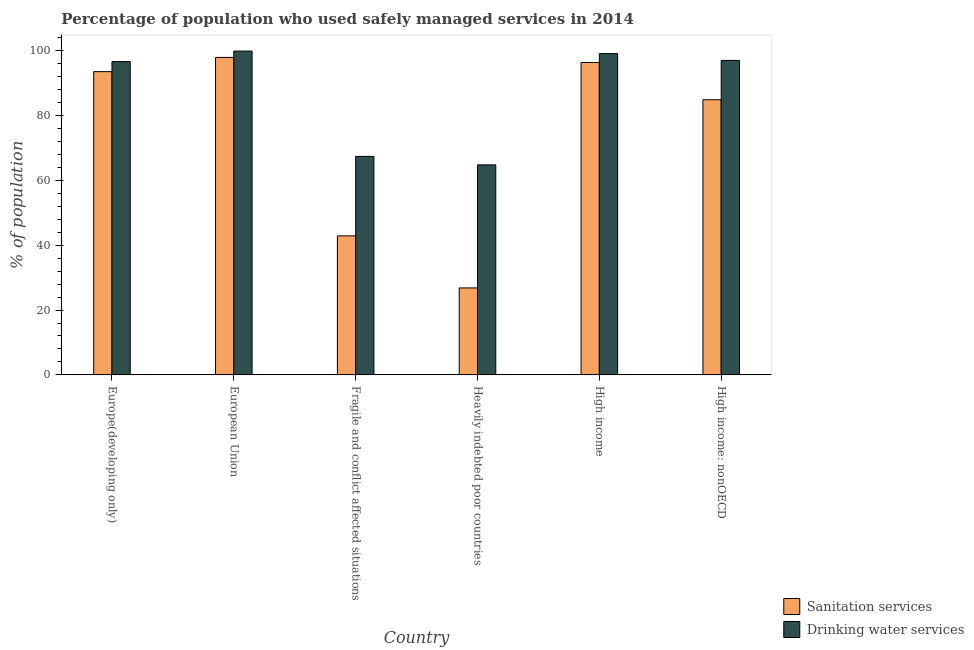How many different coloured bars are there?
Provide a short and direct response. 2. Are the number of bars per tick equal to the number of legend labels?
Offer a terse response. Yes. How many bars are there on the 2nd tick from the right?
Offer a terse response. 2. In how many cases, is the number of bars for a given country not equal to the number of legend labels?
Keep it short and to the point. 0. What is the percentage of population who used sanitation services in Fragile and conflict affected situations?
Keep it short and to the point. 42.85. Across all countries, what is the maximum percentage of population who used sanitation services?
Your answer should be compact. 97.85. Across all countries, what is the minimum percentage of population who used drinking water services?
Ensure brevity in your answer.  64.74. In which country was the percentage of population who used sanitation services maximum?
Make the answer very short. European Union. In which country was the percentage of population who used drinking water services minimum?
Ensure brevity in your answer.  Heavily indebted poor countries. What is the total percentage of population who used sanitation services in the graph?
Offer a very short reply. 442.12. What is the difference between the percentage of population who used sanitation services in Fragile and conflict affected situations and that in Heavily indebted poor countries?
Provide a succinct answer. 16.04. What is the difference between the percentage of population who used sanitation services in High income and the percentage of population who used drinking water services in Europe(developing only)?
Offer a very short reply. -0.28. What is the average percentage of population who used sanitation services per country?
Your answer should be compact. 73.69. What is the difference between the percentage of population who used sanitation services and percentage of population who used drinking water services in Heavily indebted poor countries?
Provide a short and direct response. -37.93. In how many countries, is the percentage of population who used drinking water services greater than 56 %?
Make the answer very short. 6. What is the ratio of the percentage of population who used drinking water services in Europe(developing only) to that in Heavily indebted poor countries?
Give a very brief answer. 1.49. What is the difference between the highest and the second highest percentage of population who used sanitation services?
Give a very brief answer. 1.56. What is the difference between the highest and the lowest percentage of population who used drinking water services?
Keep it short and to the point. 35.07. Is the sum of the percentage of population who used sanitation services in Fragile and conflict affected situations and High income greater than the maximum percentage of population who used drinking water services across all countries?
Give a very brief answer. Yes. What does the 1st bar from the left in European Union represents?
Ensure brevity in your answer.  Sanitation services. What does the 2nd bar from the right in High income: nonOECD represents?
Offer a terse response. Sanitation services. What is the difference between two consecutive major ticks on the Y-axis?
Your response must be concise. 20. Are the values on the major ticks of Y-axis written in scientific E-notation?
Keep it short and to the point. No. Does the graph contain grids?
Make the answer very short. No. Where does the legend appear in the graph?
Provide a succinct answer. Bottom right. How are the legend labels stacked?
Keep it short and to the point. Vertical. What is the title of the graph?
Make the answer very short. Percentage of population who used safely managed services in 2014. Does "Revenue" appear as one of the legend labels in the graph?
Offer a very short reply. No. What is the label or title of the Y-axis?
Your response must be concise. % of population. What is the % of population of Sanitation services in Europe(developing only)?
Your response must be concise. 93.48. What is the % of population in Drinking water services in Europe(developing only)?
Your answer should be compact. 96.58. What is the % of population of Sanitation services in European Union?
Your answer should be very brief. 97.85. What is the % of population in Drinking water services in European Union?
Ensure brevity in your answer.  99.82. What is the % of population in Sanitation services in Fragile and conflict affected situations?
Your answer should be very brief. 42.85. What is the % of population in Drinking water services in Fragile and conflict affected situations?
Make the answer very short. 67.35. What is the % of population in Sanitation services in Heavily indebted poor countries?
Your answer should be very brief. 26.82. What is the % of population in Drinking water services in Heavily indebted poor countries?
Ensure brevity in your answer.  64.74. What is the % of population of Sanitation services in High income?
Your answer should be very brief. 96.3. What is the % of population in Drinking water services in High income?
Offer a very short reply. 99.04. What is the % of population in Sanitation services in High income: nonOECD?
Offer a terse response. 84.82. What is the % of population of Drinking water services in High income: nonOECD?
Your response must be concise. 96.93. Across all countries, what is the maximum % of population of Sanitation services?
Your response must be concise. 97.85. Across all countries, what is the maximum % of population of Drinking water services?
Make the answer very short. 99.82. Across all countries, what is the minimum % of population in Sanitation services?
Your response must be concise. 26.82. Across all countries, what is the minimum % of population in Drinking water services?
Ensure brevity in your answer.  64.74. What is the total % of population of Sanitation services in the graph?
Ensure brevity in your answer.  442.12. What is the total % of population of Drinking water services in the graph?
Provide a succinct answer. 524.46. What is the difference between the % of population of Sanitation services in Europe(developing only) and that in European Union?
Offer a terse response. -4.37. What is the difference between the % of population in Drinking water services in Europe(developing only) and that in European Union?
Offer a terse response. -3.24. What is the difference between the % of population in Sanitation services in Europe(developing only) and that in Fragile and conflict affected situations?
Provide a short and direct response. 50.62. What is the difference between the % of population of Drinking water services in Europe(developing only) and that in Fragile and conflict affected situations?
Your response must be concise. 29.22. What is the difference between the % of population in Sanitation services in Europe(developing only) and that in Heavily indebted poor countries?
Keep it short and to the point. 66.66. What is the difference between the % of population in Drinking water services in Europe(developing only) and that in Heavily indebted poor countries?
Your answer should be very brief. 31.83. What is the difference between the % of population of Sanitation services in Europe(developing only) and that in High income?
Give a very brief answer. -2.82. What is the difference between the % of population of Drinking water services in Europe(developing only) and that in High income?
Provide a succinct answer. -2.47. What is the difference between the % of population of Sanitation services in Europe(developing only) and that in High income: nonOECD?
Your answer should be compact. 8.65. What is the difference between the % of population of Drinking water services in Europe(developing only) and that in High income: nonOECD?
Give a very brief answer. -0.35. What is the difference between the % of population in Sanitation services in European Union and that in Fragile and conflict affected situations?
Keep it short and to the point. 55. What is the difference between the % of population of Drinking water services in European Union and that in Fragile and conflict affected situations?
Keep it short and to the point. 32.46. What is the difference between the % of population of Sanitation services in European Union and that in Heavily indebted poor countries?
Your answer should be compact. 71.04. What is the difference between the % of population of Drinking water services in European Union and that in Heavily indebted poor countries?
Ensure brevity in your answer.  35.07. What is the difference between the % of population in Sanitation services in European Union and that in High income?
Give a very brief answer. 1.56. What is the difference between the % of population of Drinking water services in European Union and that in High income?
Your answer should be compact. 0.77. What is the difference between the % of population of Sanitation services in European Union and that in High income: nonOECD?
Your answer should be very brief. 13.03. What is the difference between the % of population of Drinking water services in European Union and that in High income: nonOECD?
Ensure brevity in your answer.  2.89. What is the difference between the % of population in Sanitation services in Fragile and conflict affected situations and that in Heavily indebted poor countries?
Your response must be concise. 16.04. What is the difference between the % of population of Drinking water services in Fragile and conflict affected situations and that in Heavily indebted poor countries?
Your answer should be compact. 2.61. What is the difference between the % of population of Sanitation services in Fragile and conflict affected situations and that in High income?
Your answer should be very brief. -53.44. What is the difference between the % of population of Drinking water services in Fragile and conflict affected situations and that in High income?
Provide a short and direct response. -31.69. What is the difference between the % of population of Sanitation services in Fragile and conflict affected situations and that in High income: nonOECD?
Offer a terse response. -41.97. What is the difference between the % of population in Drinking water services in Fragile and conflict affected situations and that in High income: nonOECD?
Provide a succinct answer. -29.58. What is the difference between the % of population of Sanitation services in Heavily indebted poor countries and that in High income?
Your answer should be very brief. -69.48. What is the difference between the % of population of Drinking water services in Heavily indebted poor countries and that in High income?
Your response must be concise. -34.3. What is the difference between the % of population of Sanitation services in Heavily indebted poor countries and that in High income: nonOECD?
Ensure brevity in your answer.  -58.01. What is the difference between the % of population of Drinking water services in Heavily indebted poor countries and that in High income: nonOECD?
Provide a succinct answer. -32.19. What is the difference between the % of population in Sanitation services in High income and that in High income: nonOECD?
Provide a succinct answer. 11.47. What is the difference between the % of population in Drinking water services in High income and that in High income: nonOECD?
Give a very brief answer. 2.11. What is the difference between the % of population in Sanitation services in Europe(developing only) and the % of population in Drinking water services in European Union?
Ensure brevity in your answer.  -6.34. What is the difference between the % of population in Sanitation services in Europe(developing only) and the % of population in Drinking water services in Fragile and conflict affected situations?
Provide a succinct answer. 26.13. What is the difference between the % of population of Sanitation services in Europe(developing only) and the % of population of Drinking water services in Heavily indebted poor countries?
Provide a short and direct response. 28.73. What is the difference between the % of population in Sanitation services in Europe(developing only) and the % of population in Drinking water services in High income?
Provide a short and direct response. -5.57. What is the difference between the % of population in Sanitation services in Europe(developing only) and the % of population in Drinking water services in High income: nonOECD?
Your response must be concise. -3.45. What is the difference between the % of population in Sanitation services in European Union and the % of population in Drinking water services in Fragile and conflict affected situations?
Your response must be concise. 30.5. What is the difference between the % of population of Sanitation services in European Union and the % of population of Drinking water services in Heavily indebted poor countries?
Offer a very short reply. 33.11. What is the difference between the % of population of Sanitation services in European Union and the % of population of Drinking water services in High income?
Your response must be concise. -1.19. What is the difference between the % of population of Sanitation services in European Union and the % of population of Drinking water services in High income: nonOECD?
Provide a short and direct response. 0.92. What is the difference between the % of population in Sanitation services in Fragile and conflict affected situations and the % of population in Drinking water services in Heavily indebted poor countries?
Keep it short and to the point. -21.89. What is the difference between the % of population in Sanitation services in Fragile and conflict affected situations and the % of population in Drinking water services in High income?
Ensure brevity in your answer.  -56.19. What is the difference between the % of population in Sanitation services in Fragile and conflict affected situations and the % of population in Drinking water services in High income: nonOECD?
Provide a short and direct response. -54.08. What is the difference between the % of population in Sanitation services in Heavily indebted poor countries and the % of population in Drinking water services in High income?
Your answer should be very brief. -72.23. What is the difference between the % of population in Sanitation services in Heavily indebted poor countries and the % of population in Drinking water services in High income: nonOECD?
Your response must be concise. -70.11. What is the difference between the % of population of Sanitation services in High income and the % of population of Drinking water services in High income: nonOECD?
Make the answer very short. -0.63. What is the average % of population in Sanitation services per country?
Your answer should be very brief. 73.69. What is the average % of population of Drinking water services per country?
Give a very brief answer. 87.41. What is the difference between the % of population of Sanitation services and % of population of Drinking water services in Europe(developing only)?
Offer a terse response. -3.1. What is the difference between the % of population of Sanitation services and % of population of Drinking water services in European Union?
Your answer should be compact. -1.96. What is the difference between the % of population of Sanitation services and % of population of Drinking water services in Fragile and conflict affected situations?
Provide a short and direct response. -24.5. What is the difference between the % of population of Sanitation services and % of population of Drinking water services in Heavily indebted poor countries?
Keep it short and to the point. -37.93. What is the difference between the % of population of Sanitation services and % of population of Drinking water services in High income?
Keep it short and to the point. -2.75. What is the difference between the % of population of Sanitation services and % of population of Drinking water services in High income: nonOECD?
Offer a terse response. -12.11. What is the ratio of the % of population of Sanitation services in Europe(developing only) to that in European Union?
Provide a succinct answer. 0.96. What is the ratio of the % of population of Drinking water services in Europe(developing only) to that in European Union?
Provide a short and direct response. 0.97. What is the ratio of the % of population in Sanitation services in Europe(developing only) to that in Fragile and conflict affected situations?
Offer a terse response. 2.18. What is the ratio of the % of population of Drinking water services in Europe(developing only) to that in Fragile and conflict affected situations?
Keep it short and to the point. 1.43. What is the ratio of the % of population of Sanitation services in Europe(developing only) to that in Heavily indebted poor countries?
Keep it short and to the point. 3.49. What is the ratio of the % of population in Drinking water services in Europe(developing only) to that in Heavily indebted poor countries?
Your answer should be compact. 1.49. What is the ratio of the % of population in Sanitation services in Europe(developing only) to that in High income?
Make the answer very short. 0.97. What is the ratio of the % of population in Drinking water services in Europe(developing only) to that in High income?
Provide a succinct answer. 0.98. What is the ratio of the % of population in Sanitation services in Europe(developing only) to that in High income: nonOECD?
Your answer should be compact. 1.1. What is the ratio of the % of population of Drinking water services in Europe(developing only) to that in High income: nonOECD?
Your answer should be compact. 1. What is the ratio of the % of population in Sanitation services in European Union to that in Fragile and conflict affected situations?
Offer a terse response. 2.28. What is the ratio of the % of population in Drinking water services in European Union to that in Fragile and conflict affected situations?
Offer a terse response. 1.48. What is the ratio of the % of population in Sanitation services in European Union to that in Heavily indebted poor countries?
Offer a terse response. 3.65. What is the ratio of the % of population of Drinking water services in European Union to that in Heavily indebted poor countries?
Your answer should be compact. 1.54. What is the ratio of the % of population of Sanitation services in European Union to that in High income?
Offer a terse response. 1.02. What is the ratio of the % of population in Drinking water services in European Union to that in High income?
Give a very brief answer. 1.01. What is the ratio of the % of population of Sanitation services in European Union to that in High income: nonOECD?
Offer a very short reply. 1.15. What is the ratio of the % of population in Drinking water services in European Union to that in High income: nonOECD?
Make the answer very short. 1.03. What is the ratio of the % of population of Sanitation services in Fragile and conflict affected situations to that in Heavily indebted poor countries?
Offer a very short reply. 1.6. What is the ratio of the % of population of Drinking water services in Fragile and conflict affected situations to that in Heavily indebted poor countries?
Your response must be concise. 1.04. What is the ratio of the % of population of Sanitation services in Fragile and conflict affected situations to that in High income?
Provide a succinct answer. 0.45. What is the ratio of the % of population of Drinking water services in Fragile and conflict affected situations to that in High income?
Provide a short and direct response. 0.68. What is the ratio of the % of population in Sanitation services in Fragile and conflict affected situations to that in High income: nonOECD?
Ensure brevity in your answer.  0.51. What is the ratio of the % of population of Drinking water services in Fragile and conflict affected situations to that in High income: nonOECD?
Offer a very short reply. 0.69. What is the ratio of the % of population in Sanitation services in Heavily indebted poor countries to that in High income?
Give a very brief answer. 0.28. What is the ratio of the % of population in Drinking water services in Heavily indebted poor countries to that in High income?
Give a very brief answer. 0.65. What is the ratio of the % of population of Sanitation services in Heavily indebted poor countries to that in High income: nonOECD?
Your response must be concise. 0.32. What is the ratio of the % of population in Drinking water services in Heavily indebted poor countries to that in High income: nonOECD?
Keep it short and to the point. 0.67. What is the ratio of the % of population of Sanitation services in High income to that in High income: nonOECD?
Provide a short and direct response. 1.14. What is the ratio of the % of population of Drinking water services in High income to that in High income: nonOECD?
Your answer should be compact. 1.02. What is the difference between the highest and the second highest % of population of Sanitation services?
Your response must be concise. 1.56. What is the difference between the highest and the second highest % of population in Drinking water services?
Ensure brevity in your answer.  0.77. What is the difference between the highest and the lowest % of population in Sanitation services?
Keep it short and to the point. 71.04. What is the difference between the highest and the lowest % of population of Drinking water services?
Give a very brief answer. 35.07. 